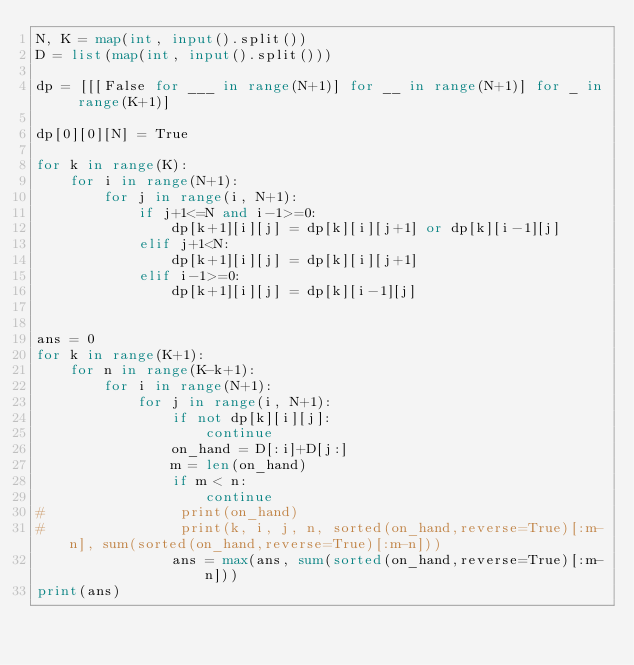Convert code to text. <code><loc_0><loc_0><loc_500><loc_500><_Python_>N, K = map(int, input().split())
D = list(map(int, input().split()))

dp = [[[False for ___ in range(N+1)] for __ in range(N+1)] for _ in range(K+1)]

dp[0][0][N] = True

for k in range(K):
    for i in range(N+1):
        for j in range(i, N+1):
            if j+1<=N and i-1>=0:
                dp[k+1][i][j] = dp[k][i][j+1] or dp[k][i-1][j]
            elif j+1<N:
                dp[k+1][i][j] = dp[k][i][j+1]
            elif i-1>=0:
                dp[k+1][i][j] = dp[k][i-1][j]
                

ans = 0
for k in range(K+1):
    for n in range(K-k+1):
        for i in range(N+1):
            for j in range(i, N+1):
                if not dp[k][i][j]:
                    continue
                on_hand = D[:i]+D[j:]
                m = len(on_hand)
                if m < n:
                    continue
#                print(on_hand)
#                print(k, i, j, n, sorted(on_hand,reverse=True)[:m-n], sum(sorted(on_hand,reverse=True)[:m-n]))
                ans = max(ans, sum(sorted(on_hand,reverse=True)[:m-n]))
print(ans)
            
            
            
</code> 